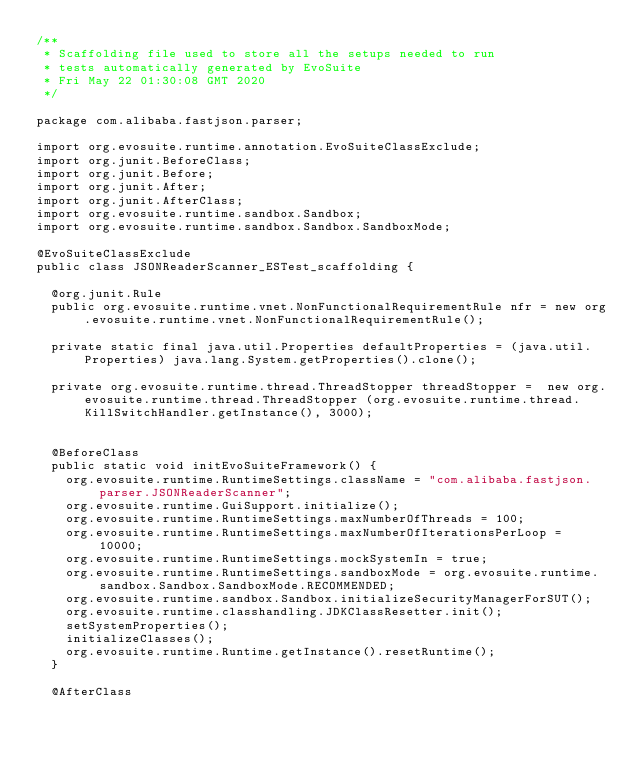Convert code to text. <code><loc_0><loc_0><loc_500><loc_500><_Java_>/**
 * Scaffolding file used to store all the setups needed to run 
 * tests automatically generated by EvoSuite
 * Fri May 22 01:30:08 GMT 2020
 */

package com.alibaba.fastjson.parser;

import org.evosuite.runtime.annotation.EvoSuiteClassExclude;
import org.junit.BeforeClass;
import org.junit.Before;
import org.junit.After;
import org.junit.AfterClass;
import org.evosuite.runtime.sandbox.Sandbox;
import org.evosuite.runtime.sandbox.Sandbox.SandboxMode;

@EvoSuiteClassExclude
public class JSONReaderScanner_ESTest_scaffolding {

  @org.junit.Rule 
  public org.evosuite.runtime.vnet.NonFunctionalRequirementRule nfr = new org.evosuite.runtime.vnet.NonFunctionalRequirementRule();

  private static final java.util.Properties defaultProperties = (java.util.Properties) java.lang.System.getProperties().clone(); 

  private org.evosuite.runtime.thread.ThreadStopper threadStopper =  new org.evosuite.runtime.thread.ThreadStopper (org.evosuite.runtime.thread.KillSwitchHandler.getInstance(), 3000);


  @BeforeClass 
  public static void initEvoSuiteFramework() { 
    org.evosuite.runtime.RuntimeSettings.className = "com.alibaba.fastjson.parser.JSONReaderScanner"; 
    org.evosuite.runtime.GuiSupport.initialize(); 
    org.evosuite.runtime.RuntimeSettings.maxNumberOfThreads = 100; 
    org.evosuite.runtime.RuntimeSettings.maxNumberOfIterationsPerLoop = 10000; 
    org.evosuite.runtime.RuntimeSettings.mockSystemIn = true; 
    org.evosuite.runtime.RuntimeSettings.sandboxMode = org.evosuite.runtime.sandbox.Sandbox.SandboxMode.RECOMMENDED; 
    org.evosuite.runtime.sandbox.Sandbox.initializeSecurityManagerForSUT(); 
    org.evosuite.runtime.classhandling.JDKClassResetter.init();
    setSystemProperties();
    initializeClasses();
    org.evosuite.runtime.Runtime.getInstance().resetRuntime(); 
  } 

  @AfterClass </code> 